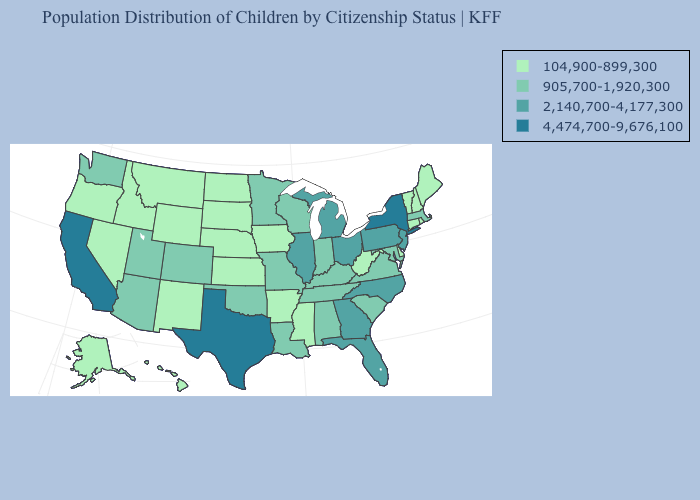Does the map have missing data?
Be succinct. No. Does the first symbol in the legend represent the smallest category?
Be succinct. Yes. Among the states that border Minnesota , which have the highest value?
Keep it brief. Wisconsin. Name the states that have a value in the range 905,700-1,920,300?
Write a very short answer. Alabama, Arizona, Colorado, Indiana, Kentucky, Louisiana, Maryland, Massachusetts, Minnesota, Missouri, Oklahoma, South Carolina, Tennessee, Utah, Virginia, Washington, Wisconsin. Does North Dakota have the lowest value in the MidWest?
Give a very brief answer. Yes. Name the states that have a value in the range 104,900-899,300?
Short answer required. Alaska, Arkansas, Connecticut, Delaware, Hawaii, Idaho, Iowa, Kansas, Maine, Mississippi, Montana, Nebraska, Nevada, New Hampshire, New Mexico, North Dakota, Oregon, Rhode Island, South Dakota, Vermont, West Virginia, Wyoming. Does Indiana have a higher value than Texas?
Quick response, please. No. Does the map have missing data?
Answer briefly. No. Name the states that have a value in the range 4,474,700-9,676,100?
Be succinct. California, New York, Texas. Which states have the lowest value in the Northeast?
Give a very brief answer. Connecticut, Maine, New Hampshire, Rhode Island, Vermont. What is the highest value in the USA?
Be succinct. 4,474,700-9,676,100. Name the states that have a value in the range 4,474,700-9,676,100?
Give a very brief answer. California, New York, Texas. What is the value of Washington?
Answer briefly. 905,700-1,920,300. Does Alabama have the same value as Missouri?
Answer briefly. Yes. What is the lowest value in the USA?
Short answer required. 104,900-899,300. 